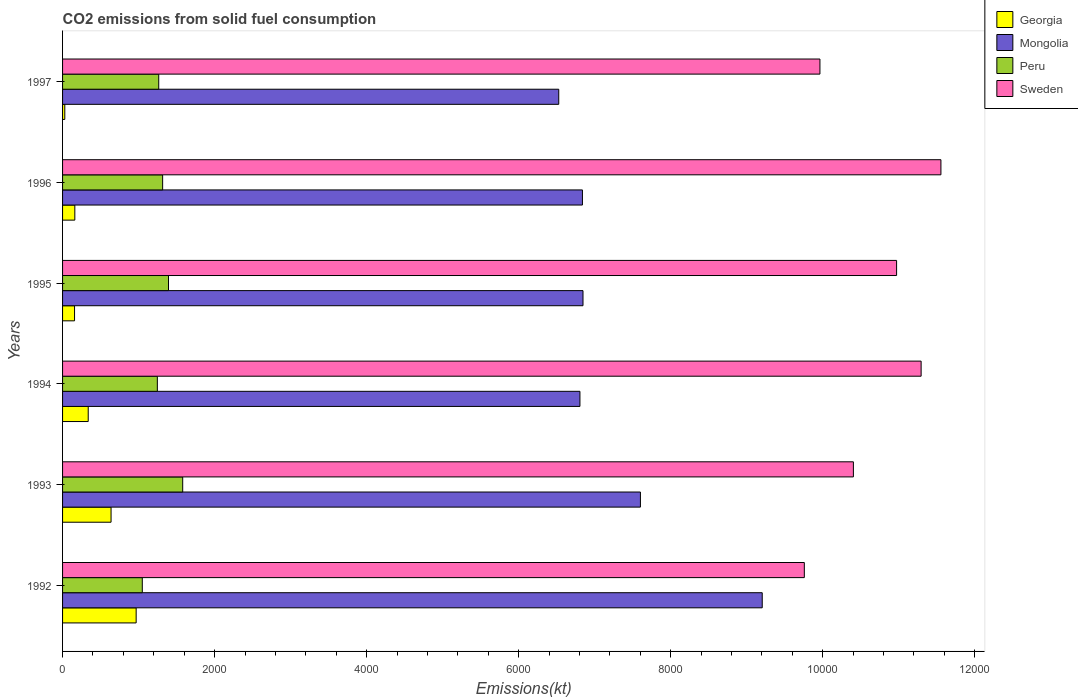How many different coloured bars are there?
Your answer should be compact. 4. What is the label of the 5th group of bars from the top?
Offer a very short reply. 1993. What is the amount of CO2 emitted in Sweden in 1993?
Make the answer very short. 1.04e+04. Across all years, what is the maximum amount of CO2 emitted in Peru?
Offer a terse response. 1580.48. Across all years, what is the minimum amount of CO2 emitted in Mongolia?
Provide a short and direct response. 6527.26. In which year was the amount of CO2 emitted in Sweden maximum?
Ensure brevity in your answer.  1996. What is the total amount of CO2 emitted in Georgia in the graph?
Your answer should be very brief. 2291.87. What is the difference between the amount of CO2 emitted in Peru in 1993 and that in 1995?
Your response must be concise. 187.02. What is the difference between the amount of CO2 emitted in Peru in 1994 and the amount of CO2 emitted in Georgia in 1993?
Your response must be concise. 608.72. What is the average amount of CO2 emitted in Georgia per year?
Give a very brief answer. 381.98. In the year 1997, what is the difference between the amount of CO2 emitted in Peru and amount of CO2 emitted in Sweden?
Provide a short and direct response. -8698.12. In how many years, is the amount of CO2 emitted in Mongolia greater than 3200 kt?
Your answer should be compact. 6. What is the ratio of the amount of CO2 emitted in Sweden in 1994 to that in 1997?
Your answer should be very brief. 1.13. Is the amount of CO2 emitted in Georgia in 1992 less than that in 1996?
Your answer should be compact. No. What is the difference between the highest and the second highest amount of CO2 emitted in Peru?
Offer a terse response. 187.02. What is the difference between the highest and the lowest amount of CO2 emitted in Mongolia?
Give a very brief answer. 2676.91. In how many years, is the amount of CO2 emitted in Mongolia greater than the average amount of CO2 emitted in Mongolia taken over all years?
Offer a very short reply. 2. Is the sum of the amount of CO2 emitted in Sweden in 1994 and 1997 greater than the maximum amount of CO2 emitted in Peru across all years?
Ensure brevity in your answer.  Yes. What does the 2nd bar from the top in 1992 represents?
Offer a terse response. Peru. What does the 4th bar from the bottom in 1993 represents?
Keep it short and to the point. Sweden. How many bars are there?
Offer a very short reply. 24. Are all the bars in the graph horizontal?
Give a very brief answer. Yes. How many years are there in the graph?
Offer a very short reply. 6. Are the values on the major ticks of X-axis written in scientific E-notation?
Ensure brevity in your answer.  No. Does the graph contain grids?
Make the answer very short. No. How many legend labels are there?
Provide a succinct answer. 4. What is the title of the graph?
Make the answer very short. CO2 emissions from solid fuel consumption. Does "Sri Lanka" appear as one of the legend labels in the graph?
Ensure brevity in your answer.  No. What is the label or title of the X-axis?
Your answer should be very brief. Emissions(kt). What is the label or title of the Y-axis?
Offer a terse response. Years. What is the Emissions(kt) of Georgia in 1992?
Provide a succinct answer. 968.09. What is the Emissions(kt) of Mongolia in 1992?
Offer a very short reply. 9204.17. What is the Emissions(kt) in Peru in 1992?
Provide a short and direct response. 1048.76. What is the Emissions(kt) of Sweden in 1992?
Your answer should be very brief. 9757.89. What is the Emissions(kt) in Georgia in 1993?
Make the answer very short. 638.06. What is the Emissions(kt) of Mongolia in 1993?
Your answer should be compact. 7601.69. What is the Emissions(kt) in Peru in 1993?
Give a very brief answer. 1580.48. What is the Emissions(kt) of Sweden in 1993?
Your answer should be compact. 1.04e+04. What is the Emissions(kt) of Georgia in 1994?
Your answer should be compact. 337.36. What is the Emissions(kt) in Mongolia in 1994?
Give a very brief answer. 6805.95. What is the Emissions(kt) in Peru in 1994?
Offer a very short reply. 1246.78. What is the Emissions(kt) of Sweden in 1994?
Offer a very short reply. 1.13e+04. What is the Emissions(kt) in Georgia in 1995?
Offer a very short reply. 157.68. What is the Emissions(kt) in Mongolia in 1995?
Offer a very short reply. 6846.29. What is the Emissions(kt) of Peru in 1995?
Offer a terse response. 1393.46. What is the Emissions(kt) of Sweden in 1995?
Provide a short and direct response. 1.10e+04. What is the Emissions(kt) in Georgia in 1996?
Your answer should be compact. 161.35. What is the Emissions(kt) of Mongolia in 1996?
Your answer should be very brief. 6838.95. What is the Emissions(kt) in Peru in 1996?
Provide a short and direct response. 1316.45. What is the Emissions(kt) in Sweden in 1996?
Provide a succinct answer. 1.16e+04. What is the Emissions(kt) of Georgia in 1997?
Your answer should be compact. 29.34. What is the Emissions(kt) of Mongolia in 1997?
Give a very brief answer. 6527.26. What is the Emissions(kt) in Peru in 1997?
Provide a short and direct response. 1265.12. What is the Emissions(kt) in Sweden in 1997?
Make the answer very short. 9963.24. Across all years, what is the maximum Emissions(kt) in Georgia?
Ensure brevity in your answer.  968.09. Across all years, what is the maximum Emissions(kt) of Mongolia?
Offer a terse response. 9204.17. Across all years, what is the maximum Emissions(kt) in Peru?
Provide a succinct answer. 1580.48. Across all years, what is the maximum Emissions(kt) in Sweden?
Your answer should be compact. 1.16e+04. Across all years, what is the minimum Emissions(kt) of Georgia?
Give a very brief answer. 29.34. Across all years, what is the minimum Emissions(kt) in Mongolia?
Your answer should be compact. 6527.26. Across all years, what is the minimum Emissions(kt) in Peru?
Make the answer very short. 1048.76. Across all years, what is the minimum Emissions(kt) of Sweden?
Provide a succinct answer. 9757.89. What is the total Emissions(kt) of Georgia in the graph?
Offer a very short reply. 2291.88. What is the total Emissions(kt) in Mongolia in the graph?
Your answer should be compact. 4.38e+04. What is the total Emissions(kt) of Peru in the graph?
Provide a succinct answer. 7851.05. What is the total Emissions(kt) in Sweden in the graph?
Provide a short and direct response. 6.39e+04. What is the difference between the Emissions(kt) in Georgia in 1992 and that in 1993?
Your answer should be compact. 330.03. What is the difference between the Emissions(kt) of Mongolia in 1992 and that in 1993?
Your answer should be very brief. 1602.48. What is the difference between the Emissions(kt) in Peru in 1992 and that in 1993?
Offer a very short reply. -531.72. What is the difference between the Emissions(kt) in Sweden in 1992 and that in 1993?
Your response must be concise. -645.39. What is the difference between the Emissions(kt) in Georgia in 1992 and that in 1994?
Make the answer very short. 630.72. What is the difference between the Emissions(kt) of Mongolia in 1992 and that in 1994?
Give a very brief answer. 2398.22. What is the difference between the Emissions(kt) in Peru in 1992 and that in 1994?
Your answer should be compact. -198.02. What is the difference between the Emissions(kt) in Sweden in 1992 and that in 1994?
Your answer should be compact. -1536.47. What is the difference between the Emissions(kt) in Georgia in 1992 and that in 1995?
Make the answer very short. 810.41. What is the difference between the Emissions(kt) of Mongolia in 1992 and that in 1995?
Make the answer very short. 2357.88. What is the difference between the Emissions(kt) in Peru in 1992 and that in 1995?
Provide a succinct answer. -344.7. What is the difference between the Emissions(kt) in Sweden in 1992 and that in 1995?
Give a very brief answer. -1213.78. What is the difference between the Emissions(kt) in Georgia in 1992 and that in 1996?
Your answer should be compact. 806.74. What is the difference between the Emissions(kt) of Mongolia in 1992 and that in 1996?
Offer a very short reply. 2365.22. What is the difference between the Emissions(kt) in Peru in 1992 and that in 1996?
Keep it short and to the point. -267.69. What is the difference between the Emissions(kt) of Sweden in 1992 and that in 1996?
Keep it short and to the point. -1796.83. What is the difference between the Emissions(kt) in Georgia in 1992 and that in 1997?
Keep it short and to the point. 938.75. What is the difference between the Emissions(kt) of Mongolia in 1992 and that in 1997?
Your response must be concise. 2676.91. What is the difference between the Emissions(kt) of Peru in 1992 and that in 1997?
Offer a terse response. -216.35. What is the difference between the Emissions(kt) in Sweden in 1992 and that in 1997?
Give a very brief answer. -205.35. What is the difference between the Emissions(kt) of Georgia in 1993 and that in 1994?
Your response must be concise. 300.69. What is the difference between the Emissions(kt) of Mongolia in 1993 and that in 1994?
Make the answer very short. 795.74. What is the difference between the Emissions(kt) of Peru in 1993 and that in 1994?
Provide a succinct answer. 333.7. What is the difference between the Emissions(kt) of Sweden in 1993 and that in 1994?
Offer a very short reply. -891.08. What is the difference between the Emissions(kt) of Georgia in 1993 and that in 1995?
Your answer should be very brief. 480.38. What is the difference between the Emissions(kt) in Mongolia in 1993 and that in 1995?
Ensure brevity in your answer.  755.4. What is the difference between the Emissions(kt) in Peru in 1993 and that in 1995?
Keep it short and to the point. 187.02. What is the difference between the Emissions(kt) in Sweden in 1993 and that in 1995?
Provide a succinct answer. -568.38. What is the difference between the Emissions(kt) in Georgia in 1993 and that in 1996?
Give a very brief answer. 476.71. What is the difference between the Emissions(kt) of Mongolia in 1993 and that in 1996?
Keep it short and to the point. 762.74. What is the difference between the Emissions(kt) of Peru in 1993 and that in 1996?
Your answer should be compact. 264.02. What is the difference between the Emissions(kt) in Sweden in 1993 and that in 1996?
Make the answer very short. -1151.44. What is the difference between the Emissions(kt) in Georgia in 1993 and that in 1997?
Offer a terse response. 608.72. What is the difference between the Emissions(kt) of Mongolia in 1993 and that in 1997?
Offer a very short reply. 1074.43. What is the difference between the Emissions(kt) in Peru in 1993 and that in 1997?
Offer a terse response. 315.36. What is the difference between the Emissions(kt) of Sweden in 1993 and that in 1997?
Your answer should be very brief. 440.04. What is the difference between the Emissions(kt) of Georgia in 1994 and that in 1995?
Your answer should be very brief. 179.68. What is the difference between the Emissions(kt) in Mongolia in 1994 and that in 1995?
Offer a terse response. -40.34. What is the difference between the Emissions(kt) in Peru in 1994 and that in 1995?
Provide a succinct answer. -146.68. What is the difference between the Emissions(kt) of Sweden in 1994 and that in 1995?
Ensure brevity in your answer.  322.7. What is the difference between the Emissions(kt) of Georgia in 1994 and that in 1996?
Ensure brevity in your answer.  176.02. What is the difference between the Emissions(kt) in Mongolia in 1994 and that in 1996?
Keep it short and to the point. -33. What is the difference between the Emissions(kt) in Peru in 1994 and that in 1996?
Your response must be concise. -69.67. What is the difference between the Emissions(kt) of Sweden in 1994 and that in 1996?
Ensure brevity in your answer.  -260.36. What is the difference between the Emissions(kt) in Georgia in 1994 and that in 1997?
Give a very brief answer. 308.03. What is the difference between the Emissions(kt) in Mongolia in 1994 and that in 1997?
Your answer should be compact. 278.69. What is the difference between the Emissions(kt) of Peru in 1994 and that in 1997?
Provide a succinct answer. -18.34. What is the difference between the Emissions(kt) in Sweden in 1994 and that in 1997?
Provide a short and direct response. 1331.12. What is the difference between the Emissions(kt) of Georgia in 1995 and that in 1996?
Your answer should be compact. -3.67. What is the difference between the Emissions(kt) of Mongolia in 1995 and that in 1996?
Offer a terse response. 7.33. What is the difference between the Emissions(kt) of Peru in 1995 and that in 1996?
Provide a succinct answer. 77.01. What is the difference between the Emissions(kt) in Sweden in 1995 and that in 1996?
Your response must be concise. -583.05. What is the difference between the Emissions(kt) of Georgia in 1995 and that in 1997?
Give a very brief answer. 128.34. What is the difference between the Emissions(kt) of Mongolia in 1995 and that in 1997?
Keep it short and to the point. 319.03. What is the difference between the Emissions(kt) of Peru in 1995 and that in 1997?
Provide a short and direct response. 128.34. What is the difference between the Emissions(kt) in Sweden in 1995 and that in 1997?
Provide a short and direct response. 1008.42. What is the difference between the Emissions(kt) of Georgia in 1996 and that in 1997?
Your answer should be very brief. 132.01. What is the difference between the Emissions(kt) of Mongolia in 1996 and that in 1997?
Give a very brief answer. 311.69. What is the difference between the Emissions(kt) in Peru in 1996 and that in 1997?
Your answer should be compact. 51.34. What is the difference between the Emissions(kt) of Sweden in 1996 and that in 1997?
Ensure brevity in your answer.  1591.48. What is the difference between the Emissions(kt) in Georgia in 1992 and the Emissions(kt) in Mongolia in 1993?
Keep it short and to the point. -6633.6. What is the difference between the Emissions(kt) of Georgia in 1992 and the Emissions(kt) of Peru in 1993?
Offer a terse response. -612.39. What is the difference between the Emissions(kt) of Georgia in 1992 and the Emissions(kt) of Sweden in 1993?
Offer a very short reply. -9435.19. What is the difference between the Emissions(kt) in Mongolia in 1992 and the Emissions(kt) in Peru in 1993?
Your response must be concise. 7623.69. What is the difference between the Emissions(kt) in Mongolia in 1992 and the Emissions(kt) in Sweden in 1993?
Offer a very short reply. -1199.11. What is the difference between the Emissions(kt) in Peru in 1992 and the Emissions(kt) in Sweden in 1993?
Give a very brief answer. -9354.52. What is the difference between the Emissions(kt) in Georgia in 1992 and the Emissions(kt) in Mongolia in 1994?
Ensure brevity in your answer.  -5837.86. What is the difference between the Emissions(kt) of Georgia in 1992 and the Emissions(kt) of Peru in 1994?
Offer a very short reply. -278.69. What is the difference between the Emissions(kt) of Georgia in 1992 and the Emissions(kt) of Sweden in 1994?
Offer a very short reply. -1.03e+04. What is the difference between the Emissions(kt) in Mongolia in 1992 and the Emissions(kt) in Peru in 1994?
Offer a terse response. 7957.39. What is the difference between the Emissions(kt) in Mongolia in 1992 and the Emissions(kt) in Sweden in 1994?
Offer a terse response. -2090.19. What is the difference between the Emissions(kt) of Peru in 1992 and the Emissions(kt) of Sweden in 1994?
Your answer should be very brief. -1.02e+04. What is the difference between the Emissions(kt) of Georgia in 1992 and the Emissions(kt) of Mongolia in 1995?
Ensure brevity in your answer.  -5878.2. What is the difference between the Emissions(kt) of Georgia in 1992 and the Emissions(kt) of Peru in 1995?
Provide a succinct answer. -425.37. What is the difference between the Emissions(kt) of Georgia in 1992 and the Emissions(kt) of Sweden in 1995?
Provide a succinct answer. -1.00e+04. What is the difference between the Emissions(kt) of Mongolia in 1992 and the Emissions(kt) of Peru in 1995?
Keep it short and to the point. 7810.71. What is the difference between the Emissions(kt) of Mongolia in 1992 and the Emissions(kt) of Sweden in 1995?
Ensure brevity in your answer.  -1767.49. What is the difference between the Emissions(kt) of Peru in 1992 and the Emissions(kt) of Sweden in 1995?
Ensure brevity in your answer.  -9922.9. What is the difference between the Emissions(kt) of Georgia in 1992 and the Emissions(kt) of Mongolia in 1996?
Your answer should be very brief. -5870.87. What is the difference between the Emissions(kt) in Georgia in 1992 and the Emissions(kt) in Peru in 1996?
Your answer should be compact. -348.37. What is the difference between the Emissions(kt) in Georgia in 1992 and the Emissions(kt) in Sweden in 1996?
Provide a succinct answer. -1.06e+04. What is the difference between the Emissions(kt) in Mongolia in 1992 and the Emissions(kt) in Peru in 1996?
Your answer should be compact. 7887.72. What is the difference between the Emissions(kt) of Mongolia in 1992 and the Emissions(kt) of Sweden in 1996?
Your response must be concise. -2350.55. What is the difference between the Emissions(kt) of Peru in 1992 and the Emissions(kt) of Sweden in 1996?
Your response must be concise. -1.05e+04. What is the difference between the Emissions(kt) in Georgia in 1992 and the Emissions(kt) in Mongolia in 1997?
Your answer should be compact. -5559.17. What is the difference between the Emissions(kt) of Georgia in 1992 and the Emissions(kt) of Peru in 1997?
Your answer should be compact. -297.03. What is the difference between the Emissions(kt) of Georgia in 1992 and the Emissions(kt) of Sweden in 1997?
Provide a short and direct response. -8995.15. What is the difference between the Emissions(kt) of Mongolia in 1992 and the Emissions(kt) of Peru in 1997?
Make the answer very short. 7939.06. What is the difference between the Emissions(kt) in Mongolia in 1992 and the Emissions(kt) in Sweden in 1997?
Offer a very short reply. -759.07. What is the difference between the Emissions(kt) of Peru in 1992 and the Emissions(kt) of Sweden in 1997?
Provide a short and direct response. -8914.48. What is the difference between the Emissions(kt) in Georgia in 1993 and the Emissions(kt) in Mongolia in 1994?
Your answer should be compact. -6167.89. What is the difference between the Emissions(kt) of Georgia in 1993 and the Emissions(kt) of Peru in 1994?
Keep it short and to the point. -608.72. What is the difference between the Emissions(kt) of Georgia in 1993 and the Emissions(kt) of Sweden in 1994?
Your answer should be compact. -1.07e+04. What is the difference between the Emissions(kt) of Mongolia in 1993 and the Emissions(kt) of Peru in 1994?
Your answer should be very brief. 6354.91. What is the difference between the Emissions(kt) in Mongolia in 1993 and the Emissions(kt) in Sweden in 1994?
Provide a short and direct response. -3692.67. What is the difference between the Emissions(kt) in Peru in 1993 and the Emissions(kt) in Sweden in 1994?
Your response must be concise. -9713.88. What is the difference between the Emissions(kt) of Georgia in 1993 and the Emissions(kt) of Mongolia in 1995?
Provide a succinct answer. -6208.23. What is the difference between the Emissions(kt) of Georgia in 1993 and the Emissions(kt) of Peru in 1995?
Your response must be concise. -755.4. What is the difference between the Emissions(kt) in Georgia in 1993 and the Emissions(kt) in Sweden in 1995?
Your answer should be very brief. -1.03e+04. What is the difference between the Emissions(kt) of Mongolia in 1993 and the Emissions(kt) of Peru in 1995?
Ensure brevity in your answer.  6208.23. What is the difference between the Emissions(kt) in Mongolia in 1993 and the Emissions(kt) in Sweden in 1995?
Make the answer very short. -3369.97. What is the difference between the Emissions(kt) in Peru in 1993 and the Emissions(kt) in Sweden in 1995?
Make the answer very short. -9391.19. What is the difference between the Emissions(kt) of Georgia in 1993 and the Emissions(kt) of Mongolia in 1996?
Keep it short and to the point. -6200.9. What is the difference between the Emissions(kt) in Georgia in 1993 and the Emissions(kt) in Peru in 1996?
Make the answer very short. -678.39. What is the difference between the Emissions(kt) in Georgia in 1993 and the Emissions(kt) in Sweden in 1996?
Give a very brief answer. -1.09e+04. What is the difference between the Emissions(kt) in Mongolia in 1993 and the Emissions(kt) in Peru in 1996?
Your answer should be very brief. 6285.24. What is the difference between the Emissions(kt) in Mongolia in 1993 and the Emissions(kt) in Sweden in 1996?
Provide a short and direct response. -3953.03. What is the difference between the Emissions(kt) of Peru in 1993 and the Emissions(kt) of Sweden in 1996?
Your answer should be compact. -9974.24. What is the difference between the Emissions(kt) of Georgia in 1993 and the Emissions(kt) of Mongolia in 1997?
Your answer should be very brief. -5889.2. What is the difference between the Emissions(kt) of Georgia in 1993 and the Emissions(kt) of Peru in 1997?
Keep it short and to the point. -627.06. What is the difference between the Emissions(kt) in Georgia in 1993 and the Emissions(kt) in Sweden in 1997?
Your response must be concise. -9325.18. What is the difference between the Emissions(kt) of Mongolia in 1993 and the Emissions(kt) of Peru in 1997?
Your response must be concise. 6336.58. What is the difference between the Emissions(kt) of Mongolia in 1993 and the Emissions(kt) of Sweden in 1997?
Give a very brief answer. -2361.55. What is the difference between the Emissions(kt) in Peru in 1993 and the Emissions(kt) in Sweden in 1997?
Provide a short and direct response. -8382.76. What is the difference between the Emissions(kt) in Georgia in 1994 and the Emissions(kt) in Mongolia in 1995?
Ensure brevity in your answer.  -6508.93. What is the difference between the Emissions(kt) of Georgia in 1994 and the Emissions(kt) of Peru in 1995?
Your answer should be very brief. -1056.1. What is the difference between the Emissions(kt) in Georgia in 1994 and the Emissions(kt) in Sweden in 1995?
Offer a very short reply. -1.06e+04. What is the difference between the Emissions(kt) of Mongolia in 1994 and the Emissions(kt) of Peru in 1995?
Make the answer very short. 5412.49. What is the difference between the Emissions(kt) in Mongolia in 1994 and the Emissions(kt) in Sweden in 1995?
Provide a short and direct response. -4165.71. What is the difference between the Emissions(kt) in Peru in 1994 and the Emissions(kt) in Sweden in 1995?
Keep it short and to the point. -9724.88. What is the difference between the Emissions(kt) of Georgia in 1994 and the Emissions(kt) of Mongolia in 1996?
Your answer should be compact. -6501.59. What is the difference between the Emissions(kt) in Georgia in 1994 and the Emissions(kt) in Peru in 1996?
Keep it short and to the point. -979.09. What is the difference between the Emissions(kt) in Georgia in 1994 and the Emissions(kt) in Sweden in 1996?
Provide a short and direct response. -1.12e+04. What is the difference between the Emissions(kt) in Mongolia in 1994 and the Emissions(kt) in Peru in 1996?
Give a very brief answer. 5489.5. What is the difference between the Emissions(kt) in Mongolia in 1994 and the Emissions(kt) in Sweden in 1996?
Keep it short and to the point. -4748.77. What is the difference between the Emissions(kt) in Peru in 1994 and the Emissions(kt) in Sweden in 1996?
Keep it short and to the point. -1.03e+04. What is the difference between the Emissions(kt) in Georgia in 1994 and the Emissions(kt) in Mongolia in 1997?
Your response must be concise. -6189.9. What is the difference between the Emissions(kt) of Georgia in 1994 and the Emissions(kt) of Peru in 1997?
Make the answer very short. -927.75. What is the difference between the Emissions(kt) of Georgia in 1994 and the Emissions(kt) of Sweden in 1997?
Keep it short and to the point. -9625.88. What is the difference between the Emissions(kt) in Mongolia in 1994 and the Emissions(kt) in Peru in 1997?
Ensure brevity in your answer.  5540.84. What is the difference between the Emissions(kt) of Mongolia in 1994 and the Emissions(kt) of Sweden in 1997?
Your response must be concise. -3157.29. What is the difference between the Emissions(kt) in Peru in 1994 and the Emissions(kt) in Sweden in 1997?
Your answer should be very brief. -8716.46. What is the difference between the Emissions(kt) of Georgia in 1995 and the Emissions(kt) of Mongolia in 1996?
Your answer should be compact. -6681.27. What is the difference between the Emissions(kt) in Georgia in 1995 and the Emissions(kt) in Peru in 1996?
Your response must be concise. -1158.77. What is the difference between the Emissions(kt) of Georgia in 1995 and the Emissions(kt) of Sweden in 1996?
Your answer should be compact. -1.14e+04. What is the difference between the Emissions(kt) in Mongolia in 1995 and the Emissions(kt) in Peru in 1996?
Your answer should be very brief. 5529.84. What is the difference between the Emissions(kt) of Mongolia in 1995 and the Emissions(kt) of Sweden in 1996?
Provide a succinct answer. -4708.43. What is the difference between the Emissions(kt) of Peru in 1995 and the Emissions(kt) of Sweden in 1996?
Make the answer very short. -1.02e+04. What is the difference between the Emissions(kt) of Georgia in 1995 and the Emissions(kt) of Mongolia in 1997?
Your answer should be compact. -6369.58. What is the difference between the Emissions(kt) of Georgia in 1995 and the Emissions(kt) of Peru in 1997?
Offer a terse response. -1107.43. What is the difference between the Emissions(kt) in Georgia in 1995 and the Emissions(kt) in Sweden in 1997?
Offer a terse response. -9805.56. What is the difference between the Emissions(kt) in Mongolia in 1995 and the Emissions(kt) in Peru in 1997?
Provide a succinct answer. 5581.17. What is the difference between the Emissions(kt) of Mongolia in 1995 and the Emissions(kt) of Sweden in 1997?
Provide a short and direct response. -3116.95. What is the difference between the Emissions(kt) in Peru in 1995 and the Emissions(kt) in Sweden in 1997?
Ensure brevity in your answer.  -8569.78. What is the difference between the Emissions(kt) in Georgia in 1996 and the Emissions(kt) in Mongolia in 1997?
Offer a very short reply. -6365.91. What is the difference between the Emissions(kt) of Georgia in 1996 and the Emissions(kt) of Peru in 1997?
Your response must be concise. -1103.77. What is the difference between the Emissions(kt) of Georgia in 1996 and the Emissions(kt) of Sweden in 1997?
Keep it short and to the point. -9801.89. What is the difference between the Emissions(kt) of Mongolia in 1996 and the Emissions(kt) of Peru in 1997?
Make the answer very short. 5573.84. What is the difference between the Emissions(kt) of Mongolia in 1996 and the Emissions(kt) of Sweden in 1997?
Your answer should be compact. -3124.28. What is the difference between the Emissions(kt) in Peru in 1996 and the Emissions(kt) in Sweden in 1997?
Provide a succinct answer. -8646.79. What is the average Emissions(kt) in Georgia per year?
Keep it short and to the point. 381.98. What is the average Emissions(kt) of Mongolia per year?
Ensure brevity in your answer.  7304.05. What is the average Emissions(kt) in Peru per year?
Provide a succinct answer. 1308.51. What is the average Emissions(kt) of Sweden per year?
Offer a very short reply. 1.07e+04. In the year 1992, what is the difference between the Emissions(kt) of Georgia and Emissions(kt) of Mongolia?
Offer a terse response. -8236.08. In the year 1992, what is the difference between the Emissions(kt) of Georgia and Emissions(kt) of Peru?
Offer a very short reply. -80.67. In the year 1992, what is the difference between the Emissions(kt) in Georgia and Emissions(kt) in Sweden?
Your response must be concise. -8789.8. In the year 1992, what is the difference between the Emissions(kt) of Mongolia and Emissions(kt) of Peru?
Make the answer very short. 8155.41. In the year 1992, what is the difference between the Emissions(kt) in Mongolia and Emissions(kt) in Sweden?
Provide a short and direct response. -553.72. In the year 1992, what is the difference between the Emissions(kt) in Peru and Emissions(kt) in Sweden?
Your response must be concise. -8709.12. In the year 1993, what is the difference between the Emissions(kt) of Georgia and Emissions(kt) of Mongolia?
Make the answer very short. -6963.63. In the year 1993, what is the difference between the Emissions(kt) of Georgia and Emissions(kt) of Peru?
Provide a short and direct response. -942.42. In the year 1993, what is the difference between the Emissions(kt) in Georgia and Emissions(kt) in Sweden?
Keep it short and to the point. -9765.22. In the year 1993, what is the difference between the Emissions(kt) of Mongolia and Emissions(kt) of Peru?
Provide a short and direct response. 6021.21. In the year 1993, what is the difference between the Emissions(kt) in Mongolia and Emissions(kt) in Sweden?
Offer a terse response. -2801.59. In the year 1993, what is the difference between the Emissions(kt) of Peru and Emissions(kt) of Sweden?
Provide a short and direct response. -8822.8. In the year 1994, what is the difference between the Emissions(kt) in Georgia and Emissions(kt) in Mongolia?
Your response must be concise. -6468.59. In the year 1994, what is the difference between the Emissions(kt) in Georgia and Emissions(kt) in Peru?
Your response must be concise. -909.42. In the year 1994, what is the difference between the Emissions(kt) in Georgia and Emissions(kt) in Sweden?
Your response must be concise. -1.10e+04. In the year 1994, what is the difference between the Emissions(kt) in Mongolia and Emissions(kt) in Peru?
Provide a short and direct response. 5559.17. In the year 1994, what is the difference between the Emissions(kt) in Mongolia and Emissions(kt) in Sweden?
Keep it short and to the point. -4488.41. In the year 1994, what is the difference between the Emissions(kt) in Peru and Emissions(kt) in Sweden?
Ensure brevity in your answer.  -1.00e+04. In the year 1995, what is the difference between the Emissions(kt) of Georgia and Emissions(kt) of Mongolia?
Provide a succinct answer. -6688.61. In the year 1995, what is the difference between the Emissions(kt) of Georgia and Emissions(kt) of Peru?
Make the answer very short. -1235.78. In the year 1995, what is the difference between the Emissions(kt) of Georgia and Emissions(kt) of Sweden?
Your answer should be very brief. -1.08e+04. In the year 1995, what is the difference between the Emissions(kt) of Mongolia and Emissions(kt) of Peru?
Offer a terse response. 5452.83. In the year 1995, what is the difference between the Emissions(kt) in Mongolia and Emissions(kt) in Sweden?
Provide a succinct answer. -4125.38. In the year 1995, what is the difference between the Emissions(kt) of Peru and Emissions(kt) of Sweden?
Keep it short and to the point. -9578.2. In the year 1996, what is the difference between the Emissions(kt) in Georgia and Emissions(kt) in Mongolia?
Provide a succinct answer. -6677.61. In the year 1996, what is the difference between the Emissions(kt) in Georgia and Emissions(kt) in Peru?
Give a very brief answer. -1155.11. In the year 1996, what is the difference between the Emissions(kt) in Georgia and Emissions(kt) in Sweden?
Make the answer very short. -1.14e+04. In the year 1996, what is the difference between the Emissions(kt) in Mongolia and Emissions(kt) in Peru?
Provide a succinct answer. 5522.5. In the year 1996, what is the difference between the Emissions(kt) of Mongolia and Emissions(kt) of Sweden?
Keep it short and to the point. -4715.76. In the year 1996, what is the difference between the Emissions(kt) in Peru and Emissions(kt) in Sweden?
Offer a very short reply. -1.02e+04. In the year 1997, what is the difference between the Emissions(kt) of Georgia and Emissions(kt) of Mongolia?
Ensure brevity in your answer.  -6497.92. In the year 1997, what is the difference between the Emissions(kt) of Georgia and Emissions(kt) of Peru?
Your answer should be compact. -1235.78. In the year 1997, what is the difference between the Emissions(kt) in Georgia and Emissions(kt) in Sweden?
Keep it short and to the point. -9933.9. In the year 1997, what is the difference between the Emissions(kt) of Mongolia and Emissions(kt) of Peru?
Keep it short and to the point. 5262.15. In the year 1997, what is the difference between the Emissions(kt) of Mongolia and Emissions(kt) of Sweden?
Your response must be concise. -3435.98. In the year 1997, what is the difference between the Emissions(kt) of Peru and Emissions(kt) of Sweden?
Keep it short and to the point. -8698.12. What is the ratio of the Emissions(kt) of Georgia in 1992 to that in 1993?
Ensure brevity in your answer.  1.52. What is the ratio of the Emissions(kt) of Mongolia in 1992 to that in 1993?
Ensure brevity in your answer.  1.21. What is the ratio of the Emissions(kt) in Peru in 1992 to that in 1993?
Keep it short and to the point. 0.66. What is the ratio of the Emissions(kt) in Sweden in 1992 to that in 1993?
Offer a very short reply. 0.94. What is the ratio of the Emissions(kt) in Georgia in 1992 to that in 1994?
Keep it short and to the point. 2.87. What is the ratio of the Emissions(kt) in Mongolia in 1992 to that in 1994?
Make the answer very short. 1.35. What is the ratio of the Emissions(kt) in Peru in 1992 to that in 1994?
Provide a short and direct response. 0.84. What is the ratio of the Emissions(kt) in Sweden in 1992 to that in 1994?
Provide a succinct answer. 0.86. What is the ratio of the Emissions(kt) in Georgia in 1992 to that in 1995?
Offer a terse response. 6.14. What is the ratio of the Emissions(kt) in Mongolia in 1992 to that in 1995?
Keep it short and to the point. 1.34. What is the ratio of the Emissions(kt) in Peru in 1992 to that in 1995?
Offer a terse response. 0.75. What is the ratio of the Emissions(kt) in Sweden in 1992 to that in 1995?
Ensure brevity in your answer.  0.89. What is the ratio of the Emissions(kt) in Mongolia in 1992 to that in 1996?
Your answer should be very brief. 1.35. What is the ratio of the Emissions(kt) in Peru in 1992 to that in 1996?
Your response must be concise. 0.8. What is the ratio of the Emissions(kt) in Sweden in 1992 to that in 1996?
Your answer should be very brief. 0.84. What is the ratio of the Emissions(kt) in Georgia in 1992 to that in 1997?
Ensure brevity in your answer.  33. What is the ratio of the Emissions(kt) of Mongolia in 1992 to that in 1997?
Offer a terse response. 1.41. What is the ratio of the Emissions(kt) in Peru in 1992 to that in 1997?
Make the answer very short. 0.83. What is the ratio of the Emissions(kt) of Sweden in 1992 to that in 1997?
Provide a short and direct response. 0.98. What is the ratio of the Emissions(kt) of Georgia in 1993 to that in 1994?
Offer a very short reply. 1.89. What is the ratio of the Emissions(kt) of Mongolia in 1993 to that in 1994?
Your answer should be very brief. 1.12. What is the ratio of the Emissions(kt) of Peru in 1993 to that in 1994?
Your response must be concise. 1.27. What is the ratio of the Emissions(kt) of Sweden in 1993 to that in 1994?
Your answer should be compact. 0.92. What is the ratio of the Emissions(kt) of Georgia in 1993 to that in 1995?
Offer a terse response. 4.05. What is the ratio of the Emissions(kt) in Mongolia in 1993 to that in 1995?
Provide a short and direct response. 1.11. What is the ratio of the Emissions(kt) in Peru in 1993 to that in 1995?
Provide a short and direct response. 1.13. What is the ratio of the Emissions(kt) of Sweden in 1993 to that in 1995?
Provide a short and direct response. 0.95. What is the ratio of the Emissions(kt) in Georgia in 1993 to that in 1996?
Your response must be concise. 3.95. What is the ratio of the Emissions(kt) of Mongolia in 1993 to that in 1996?
Provide a succinct answer. 1.11. What is the ratio of the Emissions(kt) in Peru in 1993 to that in 1996?
Offer a terse response. 1.2. What is the ratio of the Emissions(kt) in Sweden in 1993 to that in 1996?
Give a very brief answer. 0.9. What is the ratio of the Emissions(kt) of Georgia in 1993 to that in 1997?
Offer a very short reply. 21.75. What is the ratio of the Emissions(kt) of Mongolia in 1993 to that in 1997?
Your response must be concise. 1.16. What is the ratio of the Emissions(kt) in Peru in 1993 to that in 1997?
Your answer should be very brief. 1.25. What is the ratio of the Emissions(kt) of Sweden in 1993 to that in 1997?
Offer a terse response. 1.04. What is the ratio of the Emissions(kt) in Georgia in 1994 to that in 1995?
Ensure brevity in your answer.  2.14. What is the ratio of the Emissions(kt) in Peru in 1994 to that in 1995?
Provide a short and direct response. 0.89. What is the ratio of the Emissions(kt) in Sweden in 1994 to that in 1995?
Offer a very short reply. 1.03. What is the ratio of the Emissions(kt) in Georgia in 1994 to that in 1996?
Your answer should be compact. 2.09. What is the ratio of the Emissions(kt) in Peru in 1994 to that in 1996?
Offer a terse response. 0.95. What is the ratio of the Emissions(kt) of Sweden in 1994 to that in 1996?
Offer a very short reply. 0.98. What is the ratio of the Emissions(kt) in Georgia in 1994 to that in 1997?
Ensure brevity in your answer.  11.5. What is the ratio of the Emissions(kt) of Mongolia in 1994 to that in 1997?
Provide a short and direct response. 1.04. What is the ratio of the Emissions(kt) in Peru in 1994 to that in 1997?
Your answer should be compact. 0.99. What is the ratio of the Emissions(kt) of Sweden in 1994 to that in 1997?
Offer a terse response. 1.13. What is the ratio of the Emissions(kt) in Georgia in 1995 to that in 1996?
Keep it short and to the point. 0.98. What is the ratio of the Emissions(kt) in Peru in 1995 to that in 1996?
Provide a short and direct response. 1.06. What is the ratio of the Emissions(kt) in Sweden in 1995 to that in 1996?
Offer a very short reply. 0.95. What is the ratio of the Emissions(kt) of Georgia in 1995 to that in 1997?
Keep it short and to the point. 5.38. What is the ratio of the Emissions(kt) in Mongolia in 1995 to that in 1997?
Make the answer very short. 1.05. What is the ratio of the Emissions(kt) in Peru in 1995 to that in 1997?
Keep it short and to the point. 1.1. What is the ratio of the Emissions(kt) in Sweden in 1995 to that in 1997?
Your response must be concise. 1.1. What is the ratio of the Emissions(kt) of Georgia in 1996 to that in 1997?
Provide a short and direct response. 5.5. What is the ratio of the Emissions(kt) of Mongolia in 1996 to that in 1997?
Your response must be concise. 1.05. What is the ratio of the Emissions(kt) of Peru in 1996 to that in 1997?
Your response must be concise. 1.04. What is the ratio of the Emissions(kt) in Sweden in 1996 to that in 1997?
Give a very brief answer. 1.16. What is the difference between the highest and the second highest Emissions(kt) in Georgia?
Offer a terse response. 330.03. What is the difference between the highest and the second highest Emissions(kt) of Mongolia?
Provide a short and direct response. 1602.48. What is the difference between the highest and the second highest Emissions(kt) of Peru?
Your answer should be compact. 187.02. What is the difference between the highest and the second highest Emissions(kt) in Sweden?
Provide a succinct answer. 260.36. What is the difference between the highest and the lowest Emissions(kt) of Georgia?
Your answer should be compact. 938.75. What is the difference between the highest and the lowest Emissions(kt) of Mongolia?
Provide a succinct answer. 2676.91. What is the difference between the highest and the lowest Emissions(kt) of Peru?
Your answer should be very brief. 531.72. What is the difference between the highest and the lowest Emissions(kt) of Sweden?
Make the answer very short. 1796.83. 